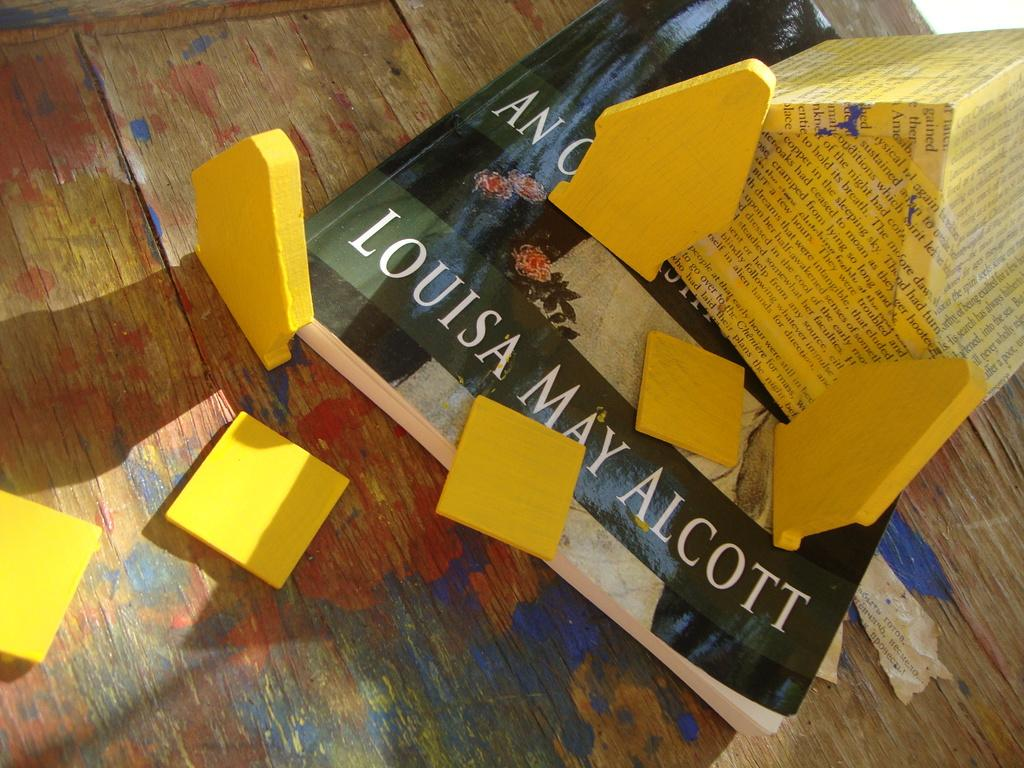<image>
Offer a succinct explanation of the picture presented. A book that is by Lousia May Alcott with post it around the book on the wood floor. 